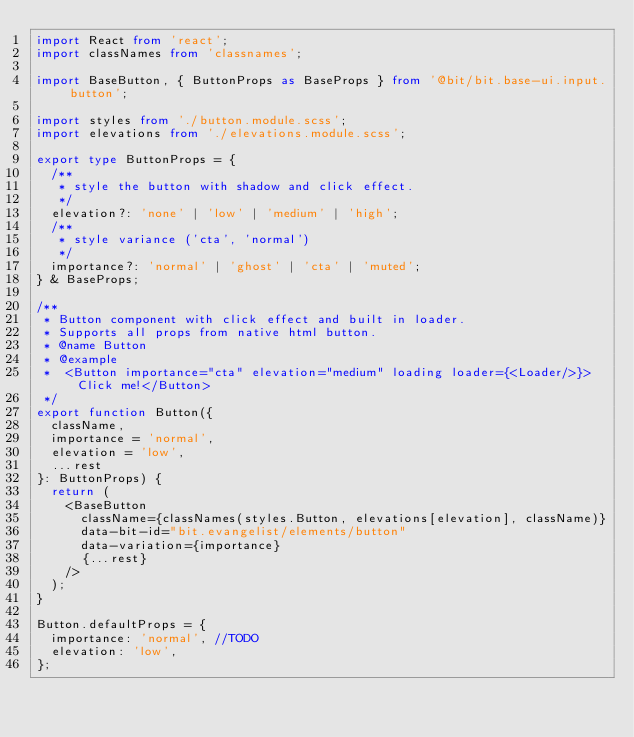<code> <loc_0><loc_0><loc_500><loc_500><_TypeScript_>import React from 'react';
import classNames from 'classnames';

import BaseButton, { ButtonProps as BaseProps } from '@bit/bit.base-ui.input.button';

import styles from './button.module.scss';
import elevations from './elevations.module.scss';

export type ButtonProps = {
	/**
	 * style the button with shadow and click effect.
	 */
	elevation?: 'none' | 'low' | 'medium' | 'high';
	/**
	 * style variance ('cta', 'normal')
	 */
	importance?: 'normal' | 'ghost' | 'cta' | 'muted';
} & BaseProps;

/**
 * Button component with click effect and built in loader.
 * Supports all props from native html button.
 * @name Button
 * @example
 * 	<Button importance="cta" elevation="medium" loading loader={<Loader/>}>Click me!</Button>
 */
export function Button({
	className,
	importance = 'normal',
	elevation = 'low',
	...rest
}: ButtonProps) {
	return (
		<BaseButton
			className={classNames(styles.Button, elevations[elevation], className)}
			data-bit-id="bit.evangelist/elements/button"
			data-variation={importance}
			{...rest}
		/>
	);
}

Button.defaultProps = {
	importance: 'normal', //TODO
	elevation: 'low',
};
</code> 